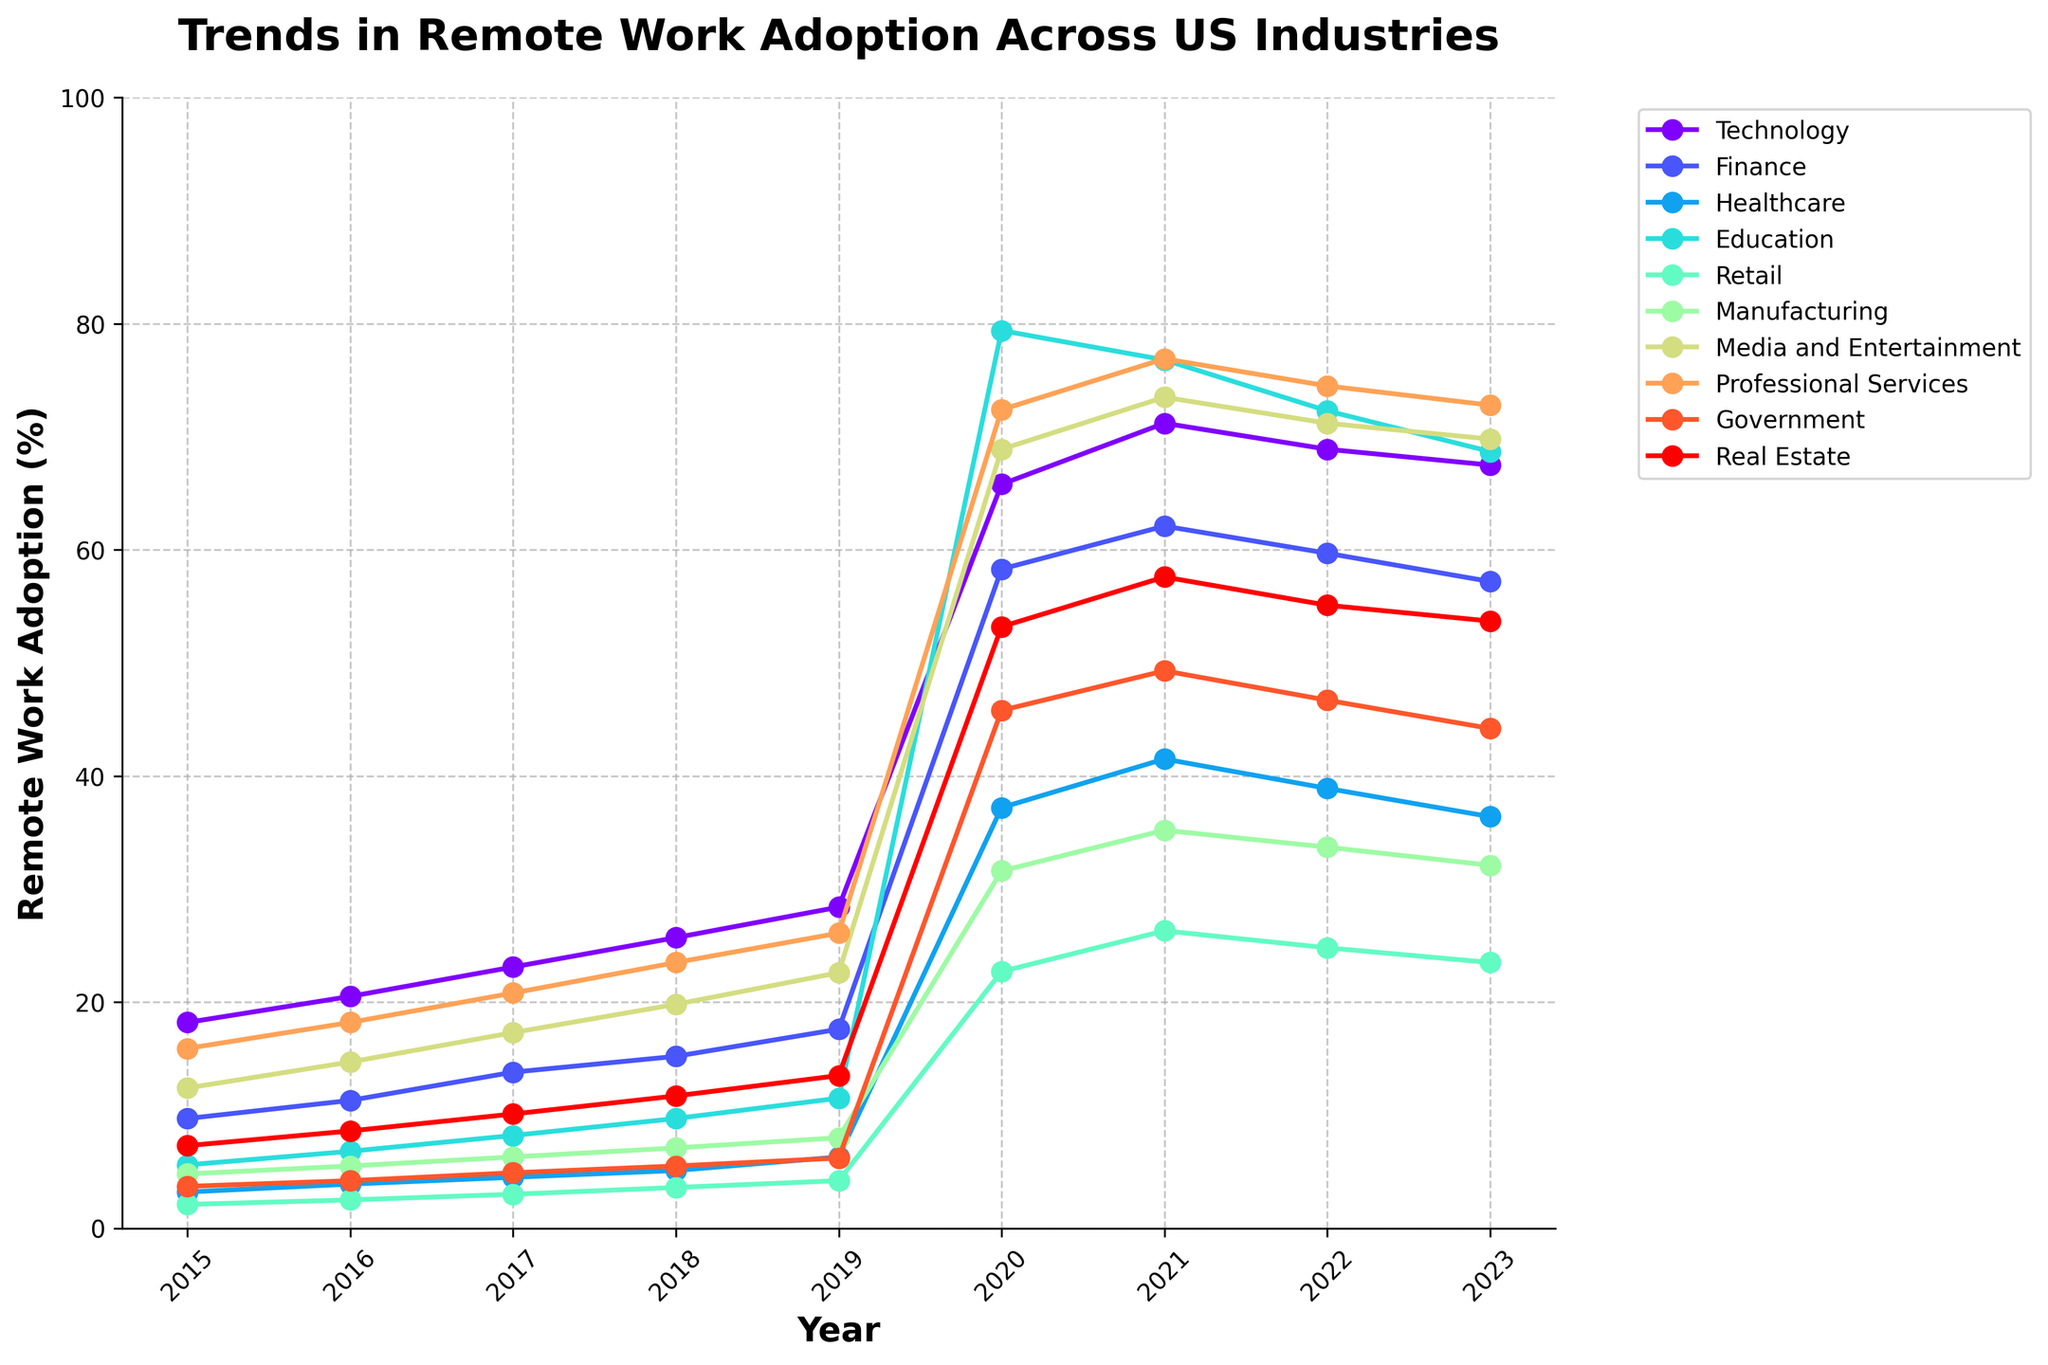Which industry has the highest remote work adoption rate in 2023? Look at the data for 2023 and find the industry with the highest percentage. The value for Education is 68.7%, which is the highest among the listed industries.
Answer: Education How much did the remote work adoption rate increase in the Healthcare industry from 2015 to 2023? Subtract the 2015 value from the 2023 value for the Healthcare industry. The 2023 value is 36.4% and the 2015 value is 3.2%, so the increase is 36.4 - 3.2 = 33.2%.
Answer: 33.2% Which industry experienced the largest increase in remote work adoption from 2019 to 2020? Calculate the difference in remote work adoption rates between 2019 and 2020 for each industry and find the largest increase. The largest increase is in Education with an increase from 11.5% to 79.4%, which is a 67.9% rise.
Answer: Education As of 2023, which industry has a lower remote work adoption rate: Real Estate or Finance? Compare the values for Real Estate and Finance in 2023. Real Estate has 53.7% and Finance has 57.2%. Since 53.7 < 57.2, Real Estate has a lower adoption rate.
Answer: Real Estate In which year did the Technology industry surpass the 50% remote work adoption rate? Identify the first year in which the Technology industry's remote work adoption rate exceeded 50%. It surpassed 50% in 2020 when it reached 65.8%.
Answer: 2020 